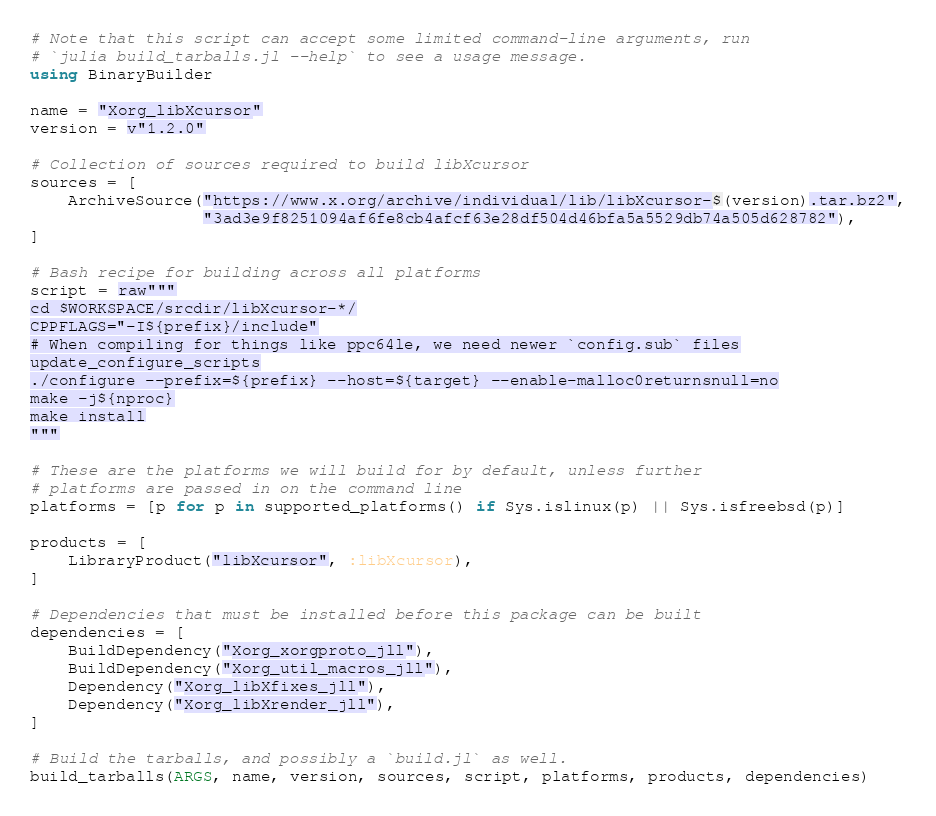<code> <loc_0><loc_0><loc_500><loc_500><_Julia_># Note that this script can accept some limited command-line arguments, run
# `julia build_tarballs.jl --help` to see a usage message.
using BinaryBuilder

name = "Xorg_libXcursor"
version = v"1.2.0"

# Collection of sources required to build libXcursor
sources = [
    ArchiveSource("https://www.x.org/archive/individual/lib/libXcursor-$(version).tar.bz2",
                  "3ad3e9f8251094af6fe8cb4afcf63e28df504d46bfa5a5529db74a505d628782"),
]

# Bash recipe for building across all platforms
script = raw"""
cd $WORKSPACE/srcdir/libXcursor-*/
CPPFLAGS="-I${prefix}/include"
# When compiling for things like ppc64le, we need newer `config.sub` files
update_configure_scripts
./configure --prefix=${prefix} --host=${target} --enable-malloc0returnsnull=no
make -j${nproc}
make install
"""

# These are the platforms we will build for by default, unless further
# platforms are passed in on the command line
platforms = [p for p in supported_platforms() if Sys.islinux(p) || Sys.isfreebsd(p)]

products = [
    LibraryProduct("libXcursor", :libXcursor),
]

# Dependencies that must be installed before this package can be built
dependencies = [
    BuildDependency("Xorg_xorgproto_jll"),
    BuildDependency("Xorg_util_macros_jll"),
    Dependency("Xorg_libXfixes_jll"),
    Dependency("Xorg_libXrender_jll"),
]

# Build the tarballs, and possibly a `build.jl` as well.
build_tarballs(ARGS, name, version, sources, script, platforms, products, dependencies)

</code> 